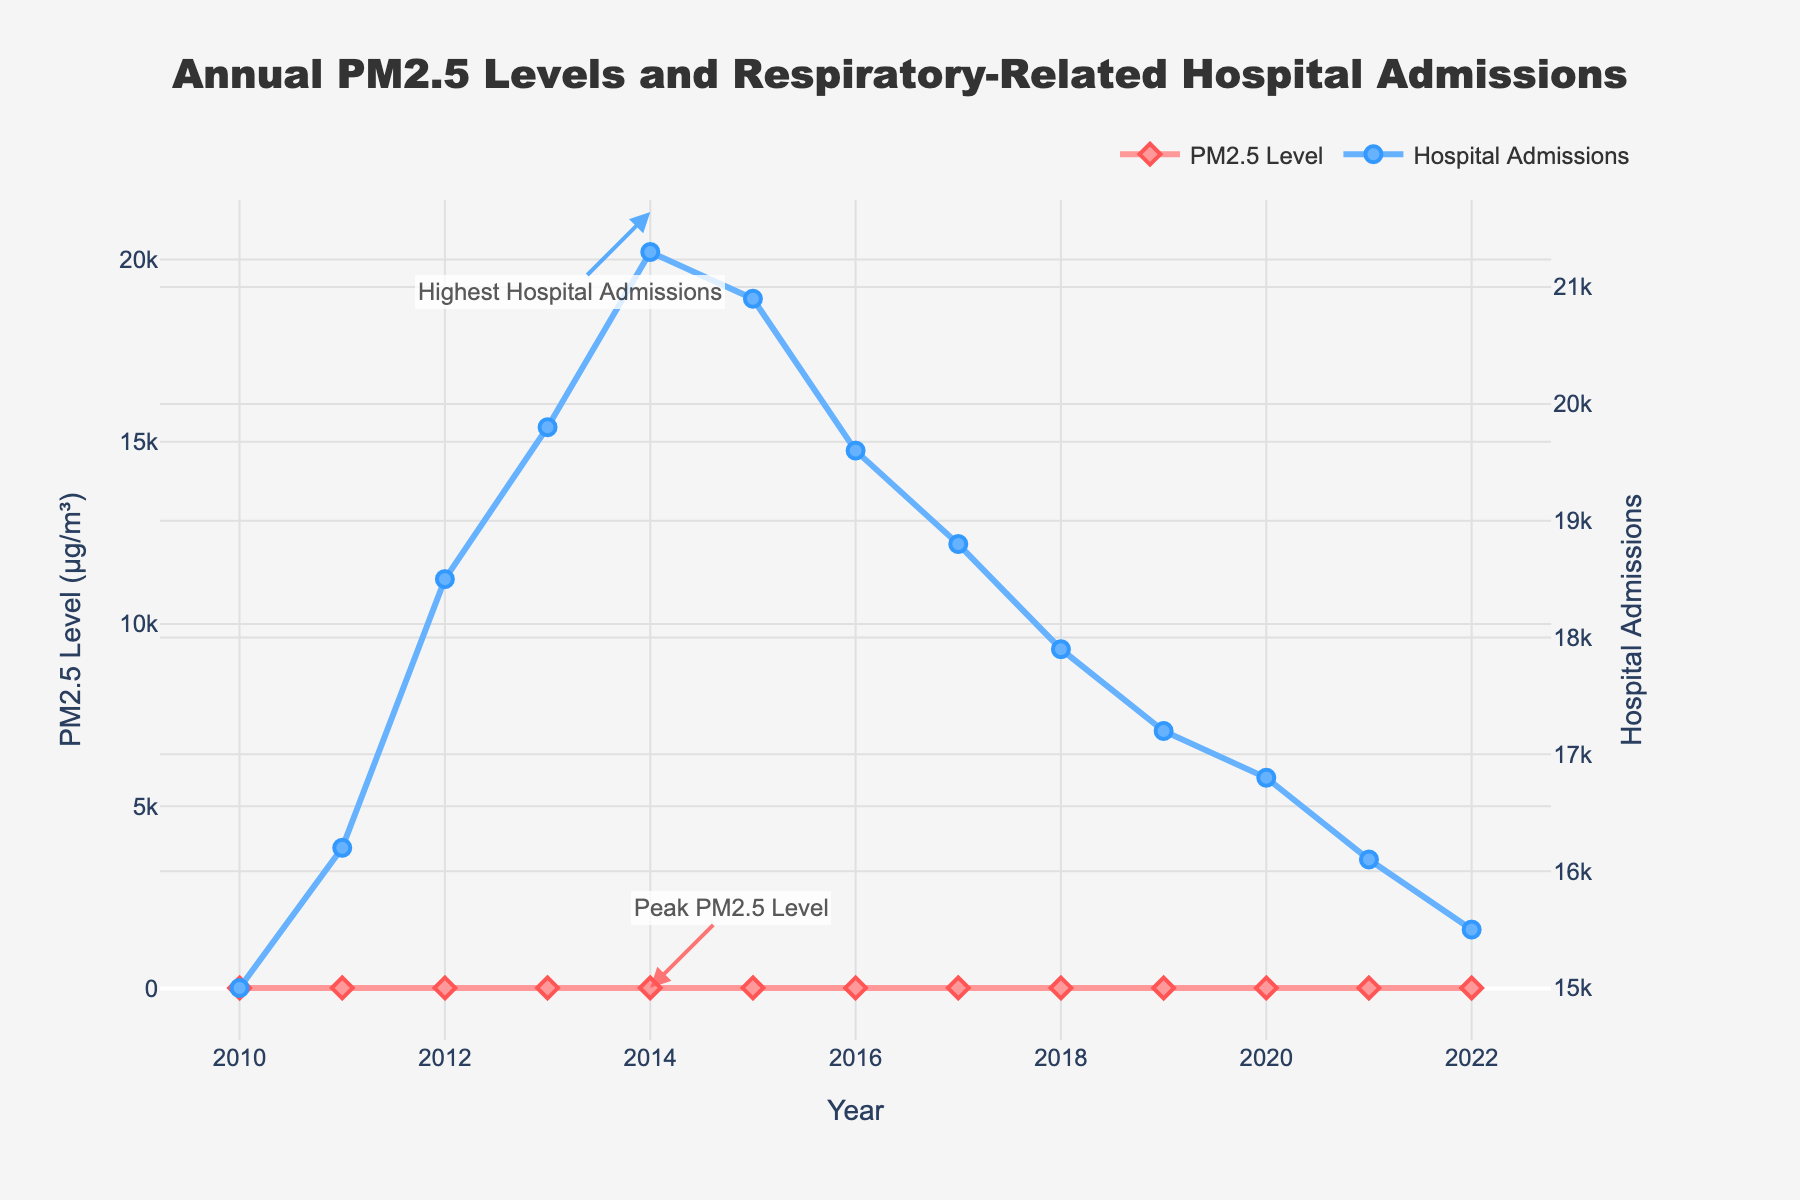What year had the highest PM2.5 level? The highest PM2.5 level was in 2014. This can be observed as the peak point on the red line corresponding to that year.
Answer: 2014 Which year experienced the peak hospital admissions? The year with the highest hospital admissions was also 2014, indicated by the peak on the blue line.
Answer: 2014 How did PM2.5 levels change from 2010 to 2014? From 2010 to 2014, PM2.5 levels increased from 12.5 to 16.1 μg/m³. This is a calculation from 12.5 in 2010 to 16.1 in 2014.
Answer: Increased What is the difference in hospital admissions between 2013 and 2017? Hospital admissions in 2013 were 19,800, and in 2017 they were 18,800, so the difference is 19,800 - 18,800 = 1,000.
Answer: 1,000 What is the trend in hospital admissions from 2018 to 2022? Hospital admissions consistently decreased from 2018 (17,900) to 2022 (15,500). This indicates a downward trend.
Answer: Decreasing How do hospital admissions in 2011 compare to those in 2021? Hospital admissions in 2011 were 16,200, whereas in 2021 they were 16,100. Thus, admissions in 2011 were slightly higher than in 2021.
Answer: Higher What is the average PM2.5 level over the entire period? To find the average, sum up all the PM2.5 levels and divide by the number of years: (12.5 + 13.2 + 14.8 + 15.5 + 16.1 + 15.8 + 14.9 + 14.2 + 13.7 + 13.1 + 12.8 + 12.3 + 11.9) / 13 ≈ 14.0.
Answer: 14.0 μg/m³ What overall trend can be observed in hospital admissions from 2010 to 2022? From 2010 to 2022, there is an initial increase in hospital admissions until 2014, followed by a general decrease. This can be seen in the rising and then falling pattern of the blue line.
Answer: Increase then Decrease In which year did PM2.5 levels just start to decline after reaching the peak? PM2.5 levels began to decline after reaching the peak in 2014. The level decreased in 2015 from 16.1 to 15.8.
Answer: 2015 How much did hospital admissions decrease from 2015 to 2022? Hospital admissions in 2015 were 20,900. In 2022, they were 15,500. The decrease is 20,900 - 15,500 = 5,400.
Answer: 5,400 